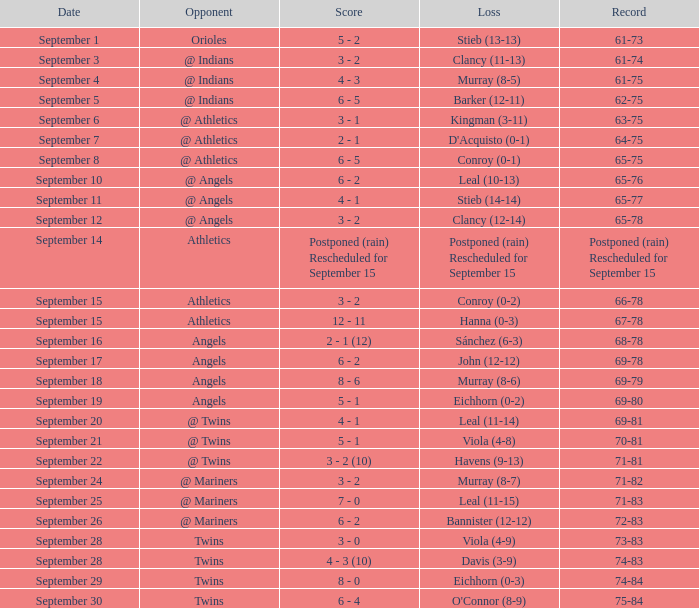Name the loss for record of 71-81 Havens (9-13). 